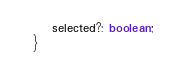<code> <loc_0><loc_0><loc_500><loc_500><_TypeScript_>    selected?: boolean;
}
</code> 